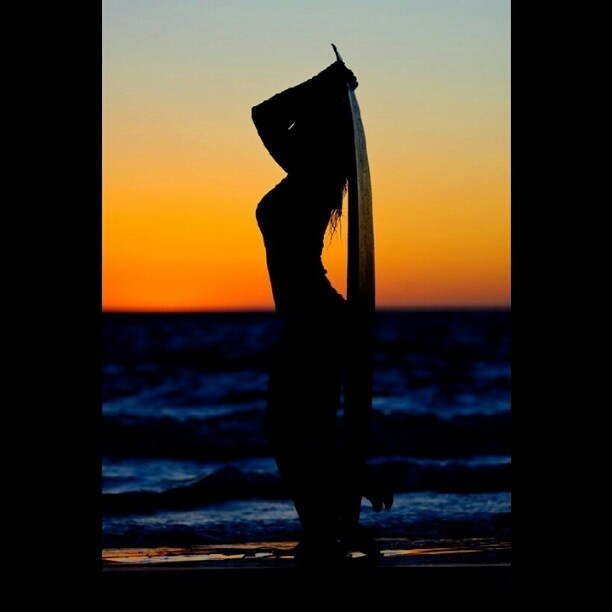Describe the objects in this image and their specific colors. I can see people in black, orange, and gray tones and surfboard in black, maroon, darkgreen, and orange tones in this image. 